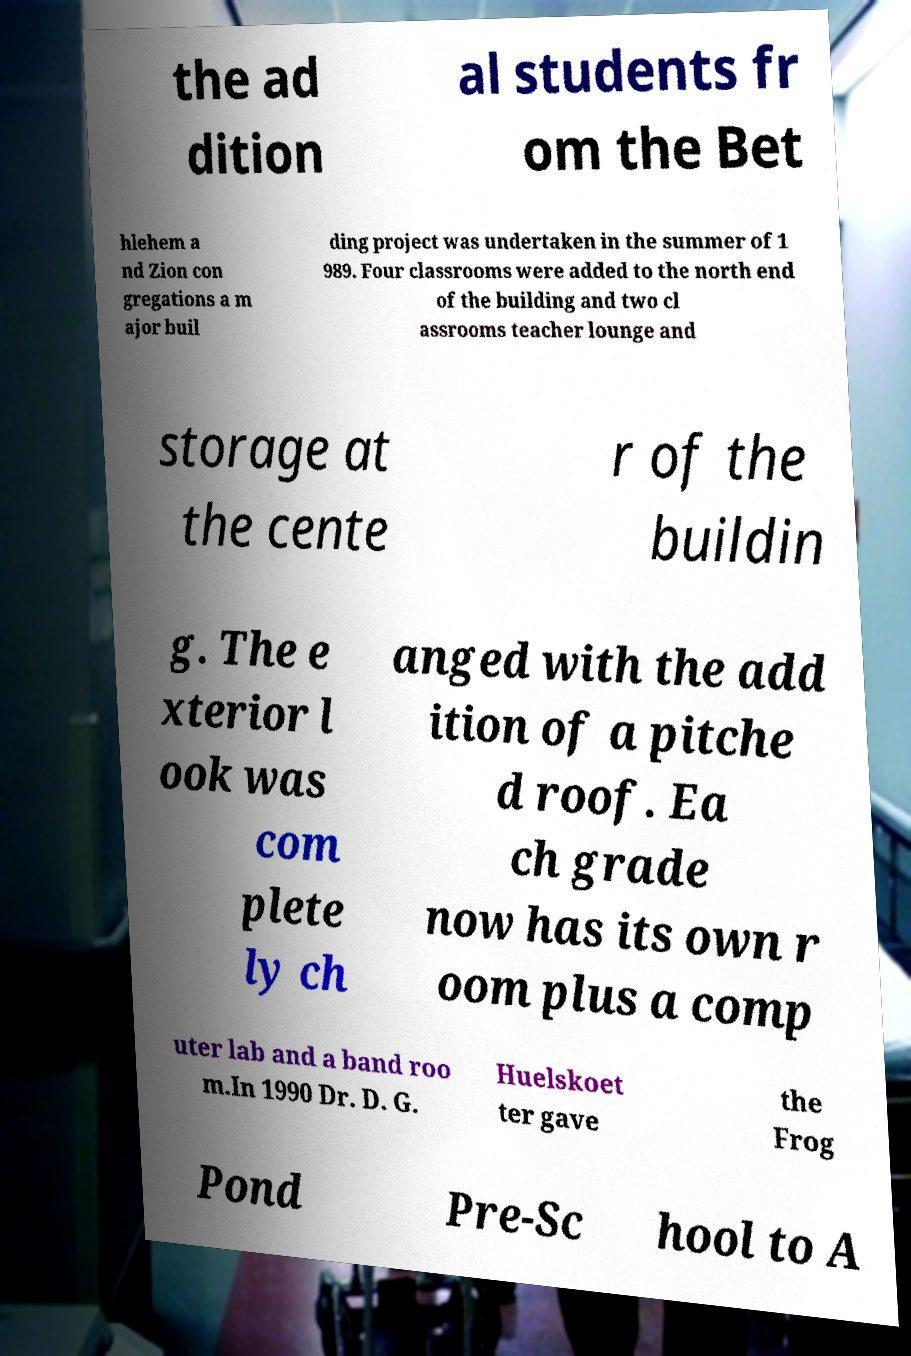Could you extract and type out the text from this image? the ad dition al students fr om the Bet hlehem a nd Zion con gregations a m ajor buil ding project was undertaken in the summer of 1 989. Four classrooms were added to the north end of the building and two cl assrooms teacher lounge and storage at the cente r of the buildin g. The e xterior l ook was com plete ly ch anged with the add ition of a pitche d roof. Ea ch grade now has its own r oom plus a comp uter lab and a band roo m.In 1990 Dr. D. G. Huelskoet ter gave the Frog Pond Pre-Sc hool to A 